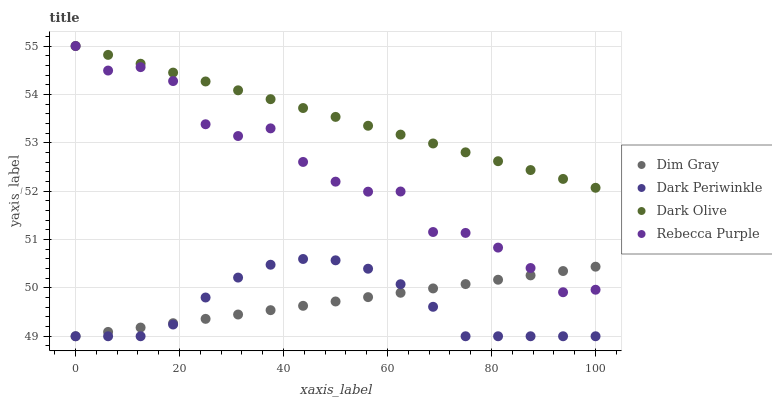Does Dark Periwinkle have the minimum area under the curve?
Answer yes or no. Yes. Does Dark Olive have the maximum area under the curve?
Answer yes or no. Yes. Does Dim Gray have the minimum area under the curve?
Answer yes or no. No. Does Dim Gray have the maximum area under the curve?
Answer yes or no. No. Is Dark Olive the smoothest?
Answer yes or no. Yes. Is Rebecca Purple the roughest?
Answer yes or no. Yes. Is Dim Gray the smoothest?
Answer yes or no. No. Is Dim Gray the roughest?
Answer yes or no. No. Does Dim Gray have the lowest value?
Answer yes or no. Yes. Does Rebecca Purple have the lowest value?
Answer yes or no. No. Does Rebecca Purple have the highest value?
Answer yes or no. Yes. Does Dark Periwinkle have the highest value?
Answer yes or no. No. Is Dark Periwinkle less than Dark Olive?
Answer yes or no. Yes. Is Rebecca Purple greater than Dark Periwinkle?
Answer yes or no. Yes. Does Dim Gray intersect Dark Periwinkle?
Answer yes or no. Yes. Is Dim Gray less than Dark Periwinkle?
Answer yes or no. No. Is Dim Gray greater than Dark Periwinkle?
Answer yes or no. No. Does Dark Periwinkle intersect Dark Olive?
Answer yes or no. No. 